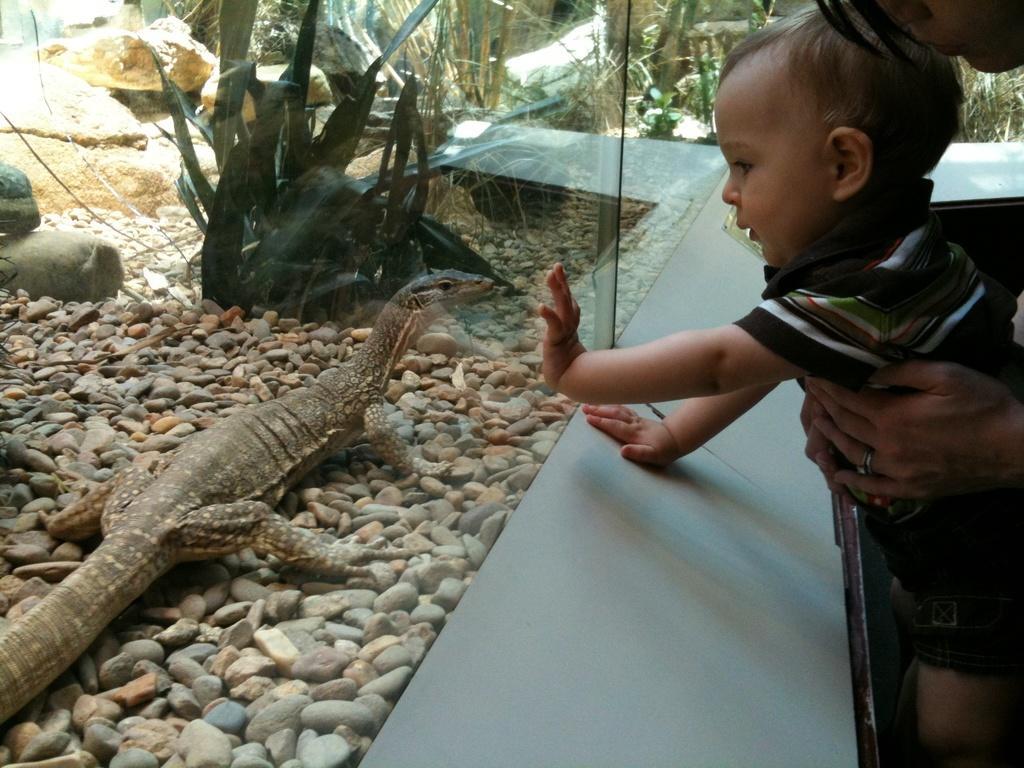How would you summarize this image in a sentence or two? In this image the person is standing and seeing a lizard. In front of him there is a glass with stones and plants. And there is a cardboard box which is blue in color. 